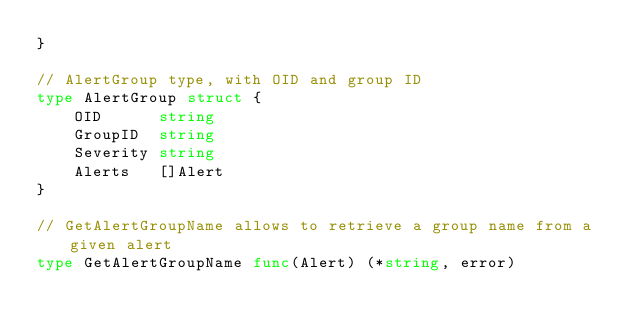<code> <loc_0><loc_0><loc_500><loc_500><_Go_>}

// AlertGroup type, with OID and group ID
type AlertGroup struct {
	OID      string
	GroupID  string
	Severity string
	Alerts   []Alert
}

// GetAlertGroupName allows to retrieve a group name from a given alert
type GetAlertGroupName func(Alert) (*string, error)
</code> 